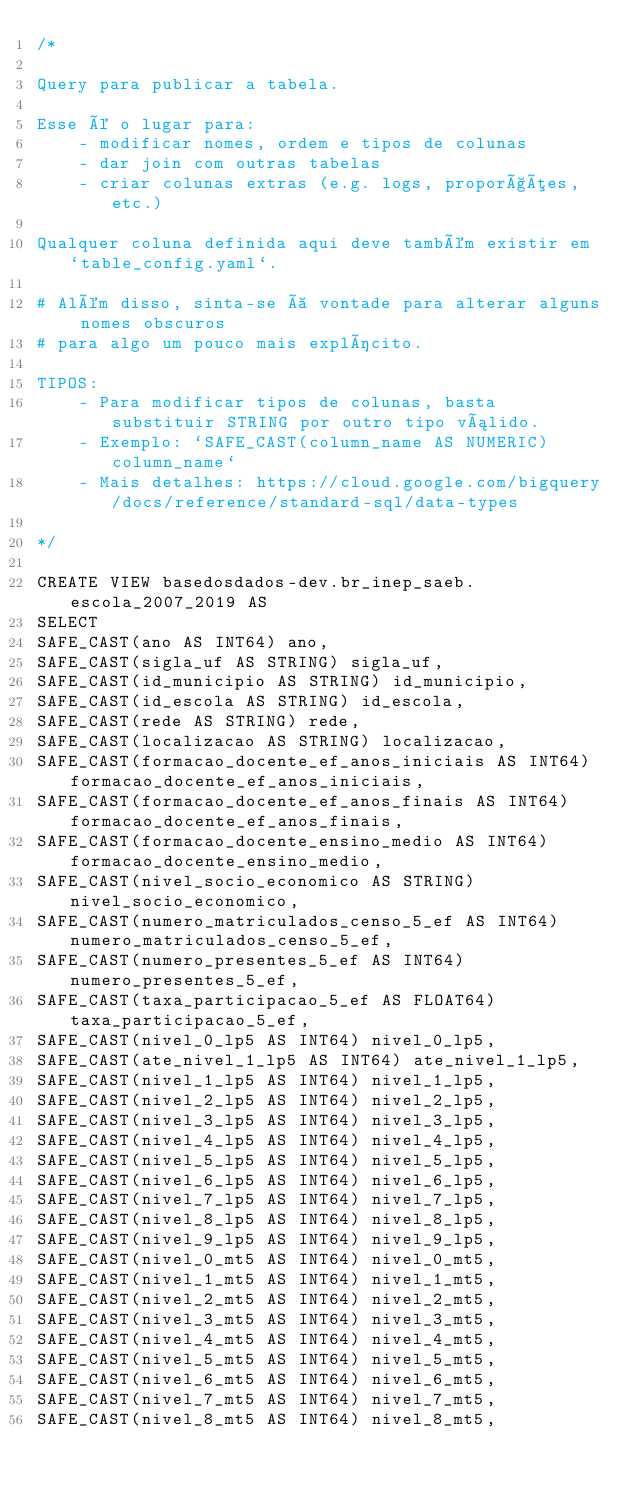Convert code to text. <code><loc_0><loc_0><loc_500><loc_500><_SQL_>/*

Query para publicar a tabela.

Esse é o lugar para:
    - modificar nomes, ordem e tipos de colunas
    - dar join com outras tabelas
    - criar colunas extras (e.g. logs, proporções, etc.)

Qualquer coluna definida aqui deve também existir em `table_config.yaml`.

# Além disso, sinta-se à vontade para alterar alguns nomes obscuros
# para algo um pouco mais explícito.

TIPOS:
    - Para modificar tipos de colunas, basta substituir STRING por outro tipo válido.
    - Exemplo: `SAFE_CAST(column_name AS NUMERIC) column_name`
    - Mais detalhes: https://cloud.google.com/bigquery/docs/reference/standard-sql/data-types

*/

CREATE VIEW basedosdados-dev.br_inep_saeb.escola_2007_2019 AS
SELECT 
SAFE_CAST(ano AS INT64) ano,
SAFE_CAST(sigla_uf AS STRING) sigla_uf,
SAFE_CAST(id_municipio AS STRING) id_municipio,
SAFE_CAST(id_escola AS STRING) id_escola,
SAFE_CAST(rede AS STRING) rede,
SAFE_CAST(localizacao AS STRING) localizacao,
SAFE_CAST(formacao_docente_ef_anos_iniciais AS INT64) formacao_docente_ef_anos_iniciais,
SAFE_CAST(formacao_docente_ef_anos_finais AS INT64) formacao_docente_ef_anos_finais,
SAFE_CAST(formacao_docente_ensino_medio AS INT64) formacao_docente_ensino_medio,
SAFE_CAST(nivel_socio_economico AS STRING) nivel_socio_economico,
SAFE_CAST(numero_matriculados_censo_5_ef AS INT64) numero_matriculados_censo_5_ef,
SAFE_CAST(numero_presentes_5_ef AS INT64) numero_presentes_5_ef,
SAFE_CAST(taxa_participacao_5_ef AS FLOAT64) taxa_participacao_5_ef,
SAFE_CAST(nivel_0_lp5 AS INT64) nivel_0_lp5,
SAFE_CAST(ate_nivel_1_lp5 AS INT64) ate_nivel_1_lp5,
SAFE_CAST(nivel_1_lp5 AS INT64) nivel_1_lp5,
SAFE_CAST(nivel_2_lp5 AS INT64) nivel_2_lp5,
SAFE_CAST(nivel_3_lp5 AS INT64) nivel_3_lp5,
SAFE_CAST(nivel_4_lp5 AS INT64) nivel_4_lp5,
SAFE_CAST(nivel_5_lp5 AS INT64) nivel_5_lp5,
SAFE_CAST(nivel_6_lp5 AS INT64) nivel_6_lp5,
SAFE_CAST(nivel_7_lp5 AS INT64) nivel_7_lp5,
SAFE_CAST(nivel_8_lp5 AS INT64) nivel_8_lp5,
SAFE_CAST(nivel_9_lp5 AS INT64) nivel_9_lp5,
SAFE_CAST(nivel_0_mt5 AS INT64) nivel_0_mt5,
SAFE_CAST(nivel_1_mt5 AS INT64) nivel_1_mt5,
SAFE_CAST(nivel_2_mt5 AS INT64) nivel_2_mt5,
SAFE_CAST(nivel_3_mt5 AS INT64) nivel_3_mt5,
SAFE_CAST(nivel_4_mt5 AS INT64) nivel_4_mt5,
SAFE_CAST(nivel_5_mt5 AS INT64) nivel_5_mt5,
SAFE_CAST(nivel_6_mt5 AS INT64) nivel_6_mt5,
SAFE_CAST(nivel_7_mt5 AS INT64) nivel_7_mt5,
SAFE_CAST(nivel_8_mt5 AS INT64) nivel_8_mt5,</code> 